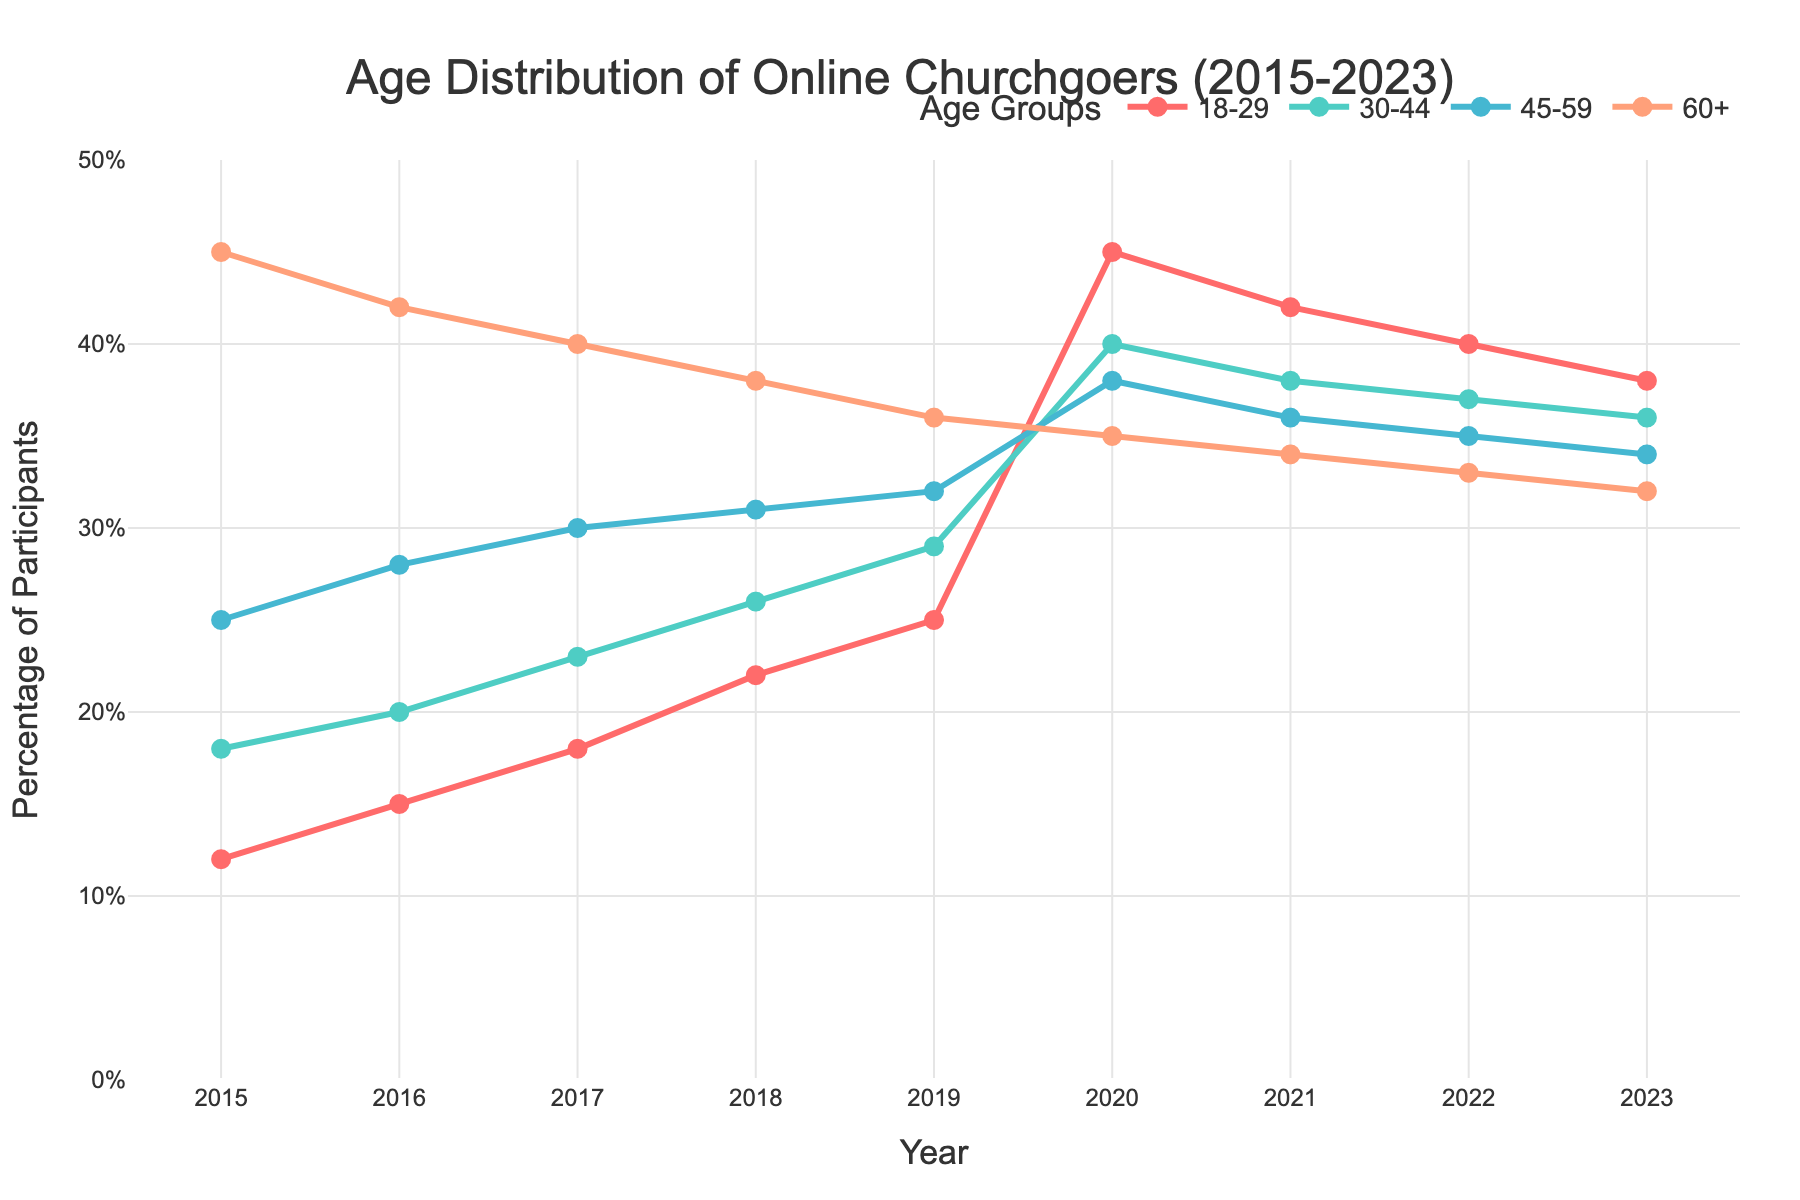What's the trend for the 18-29 age group from 2015 to 2023? The 18-29 age group starts at 12% in 2015 and steadily increases each year until 2020 where it jumps to 45%, then it slightly declines to 38% in 2023.
Answer: Increasing with a peak in 2020, then declines slightly Which year shows the highest percentage in the 18-29 age group? The highest percentage for the 18-29 age group is seen in 2020, where it reaches 45%.
Answer: 2020 How does the percentage of the 60+ age group change from 2015 to 2023? The percentage of the 60+ age group decreases steadily from 45% in 2015 to 32% in 2023.
Answer: Decreasing Compare the percentage of the 30-44 and 45-59 age groups in 2023. Which is higher? In 2023, the 30-44 age group is at 36% while the 45-59 age group is at 34%. Therefore, the 30-44 age group is higher.
Answer: 30-44 In which year do all age groups show an increase compared to the previous year? In 2020, all age groups (18-29, 30-44, 45-59) show an increase compared to the previous year (2019). The 60+ age group decreases, but all younger groups increase.
Answer: 2020 What is the difference in percentage between the 18-29 and 60+ age groups in 2015? The 18-29 group is at 12% and the 60+ group is at 45% in 2015. The difference between them is 45% - 12% = 33%.
Answer: 33% Which age group has the most significant percentage increase from 2015 to 2020? Comparing the values in 2015 and 2020, the 18-29 age group increases from 12% to 45%, which is an increase of 33%, the highest increase among all age groups.
Answer: 18-29 What is the average percentage of the 30-44 age group from 2015 to 2023? The values are [18, 20, 23, 26, 29, 40, 38, 37, 36]. The sum is 267. The average is 267/9 = 29.67%.
Answer: 29.67% In 2023, how much greater is the percentage of the 18-29 age group compared to the 60+ age group? In 2023, the 18-29 age group is at 38% and the 60+ age group is at 32%. The difference is 38% - 32% = 6%.
Answer: 6% Which age group consistently decreases every year from 2015 to 2023? The 60+ age group consistently decreases every year from 45% in 2015 to 32% in 2023.
Answer: 60+ 